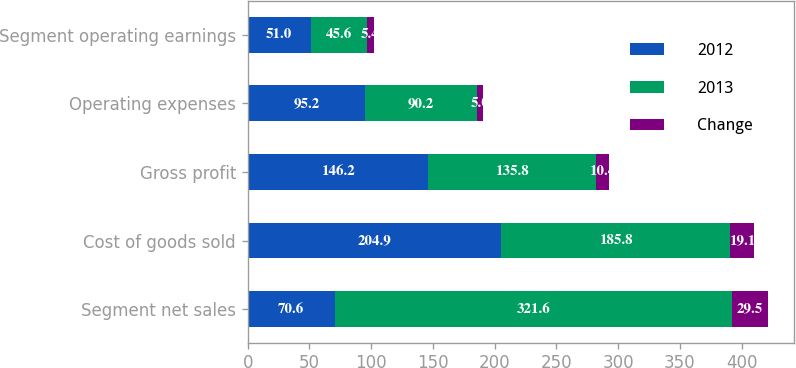Convert chart. <chart><loc_0><loc_0><loc_500><loc_500><stacked_bar_chart><ecel><fcel>Segment net sales<fcel>Cost of goods sold<fcel>Gross profit<fcel>Operating expenses<fcel>Segment operating earnings<nl><fcel>2012<fcel>70.6<fcel>204.9<fcel>146.2<fcel>95.2<fcel>51<nl><fcel>2013<fcel>321.6<fcel>185.8<fcel>135.8<fcel>90.2<fcel>45.6<nl><fcel>Change<fcel>29.5<fcel>19.1<fcel>10.4<fcel>5<fcel>5.4<nl></chart> 